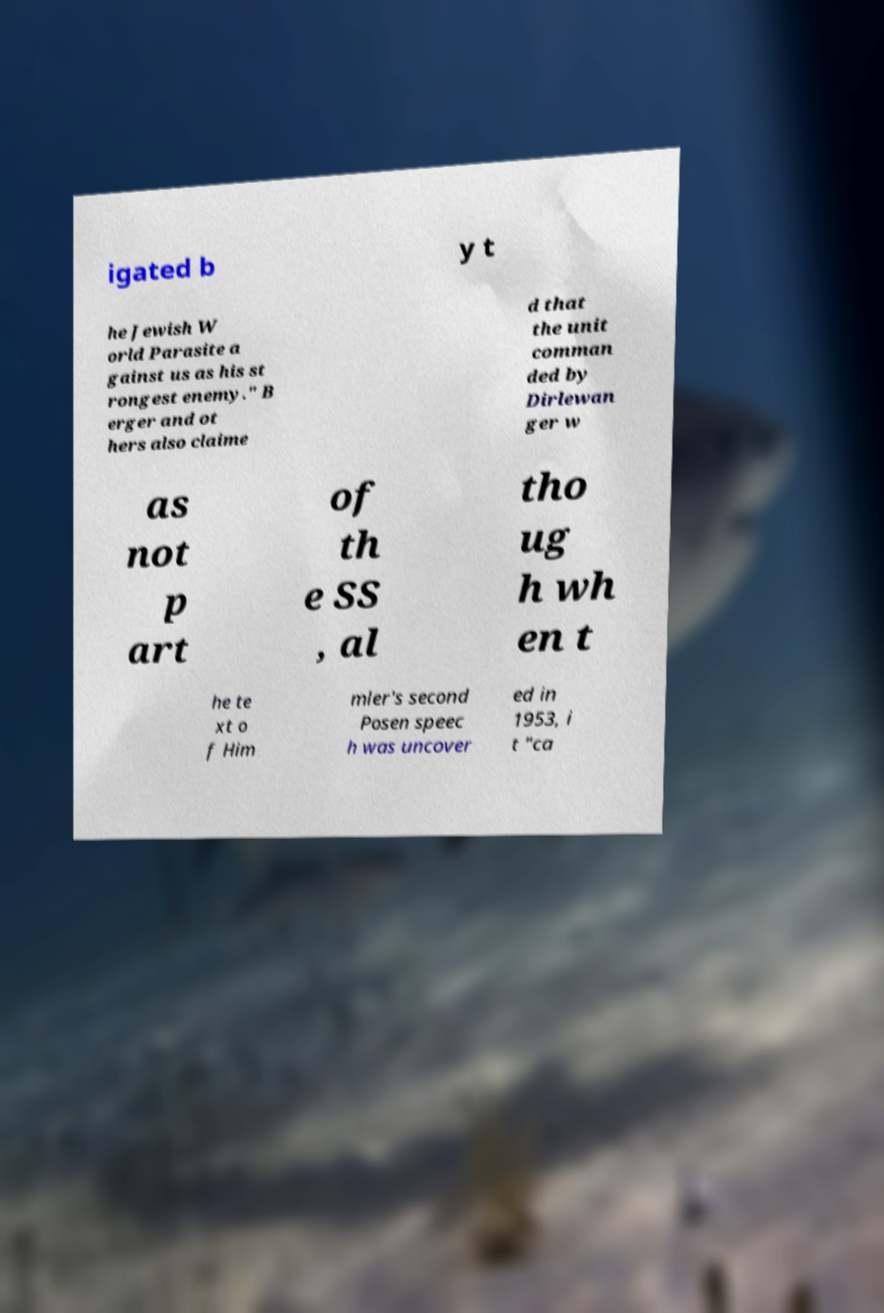Can you accurately transcribe the text from the provided image for me? igated b y t he Jewish W orld Parasite a gainst us as his st rongest enemy." B erger and ot hers also claime d that the unit comman ded by Dirlewan ger w as not p art of th e SS , al tho ug h wh en t he te xt o f Him mler's second Posen speec h was uncover ed in 1953, i t "ca 